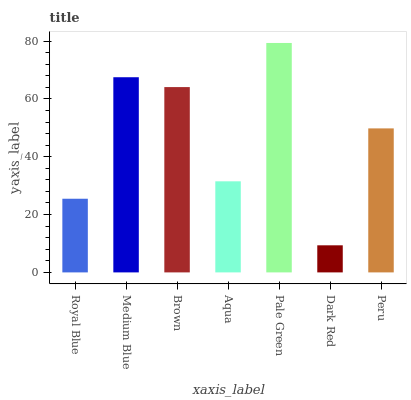Is Dark Red the minimum?
Answer yes or no. Yes. Is Pale Green the maximum?
Answer yes or no. Yes. Is Medium Blue the minimum?
Answer yes or no. No. Is Medium Blue the maximum?
Answer yes or no. No. Is Medium Blue greater than Royal Blue?
Answer yes or no. Yes. Is Royal Blue less than Medium Blue?
Answer yes or no. Yes. Is Royal Blue greater than Medium Blue?
Answer yes or no. No. Is Medium Blue less than Royal Blue?
Answer yes or no. No. Is Peru the high median?
Answer yes or no. Yes. Is Peru the low median?
Answer yes or no. Yes. Is Brown the high median?
Answer yes or no. No. Is Pale Green the low median?
Answer yes or no. No. 